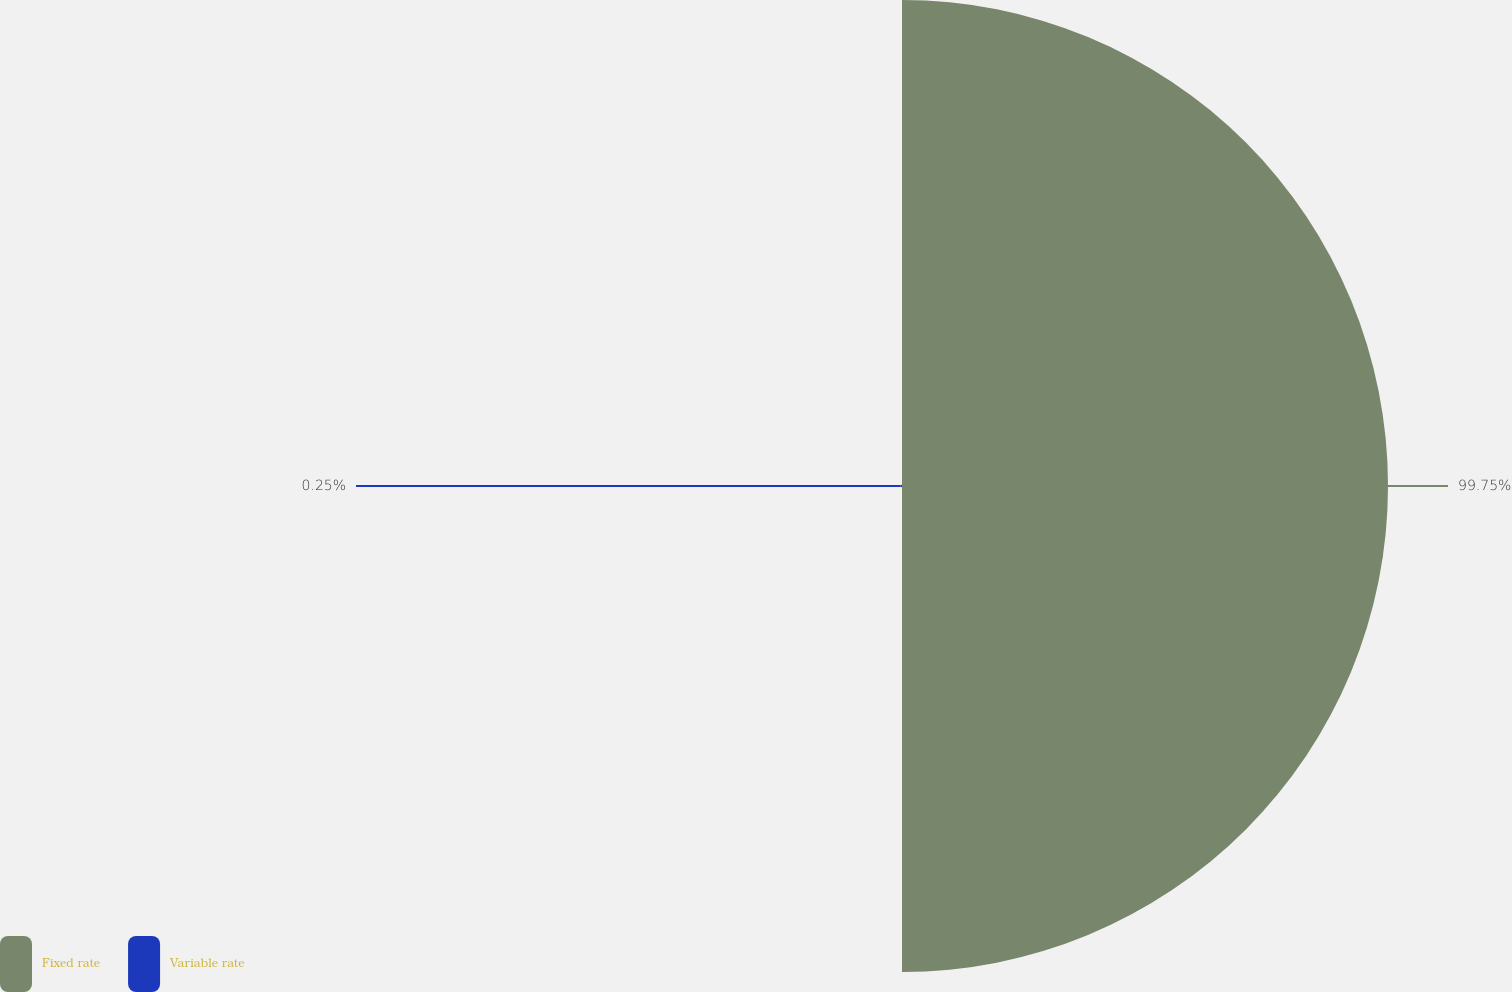Convert chart to OTSL. <chart><loc_0><loc_0><loc_500><loc_500><pie_chart><fcel>Fixed rate<fcel>Variable rate<nl><fcel>99.75%<fcel>0.25%<nl></chart> 